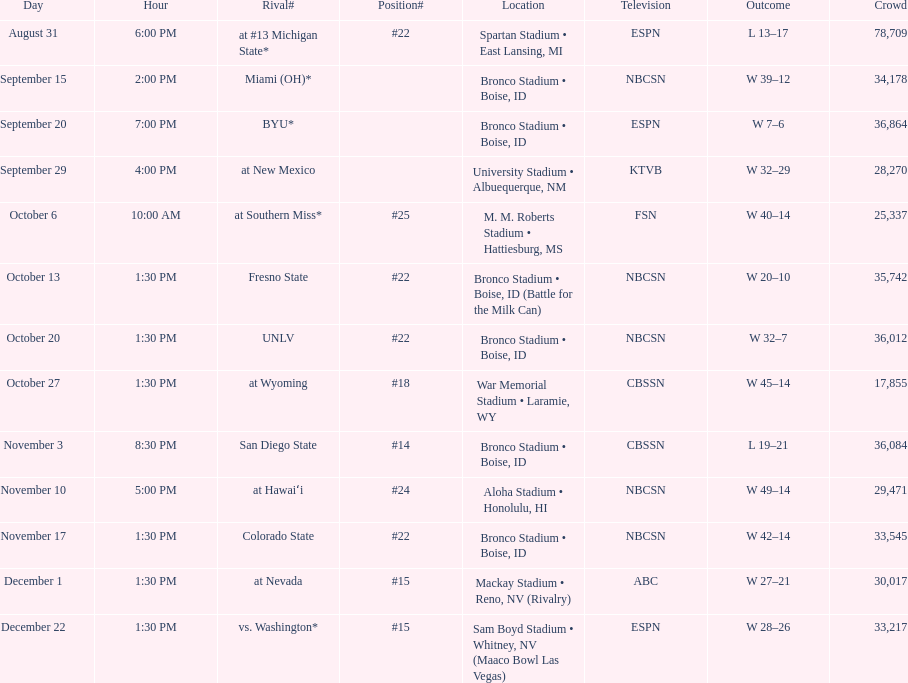Which team has the highest rank among those listed? San Diego State. 